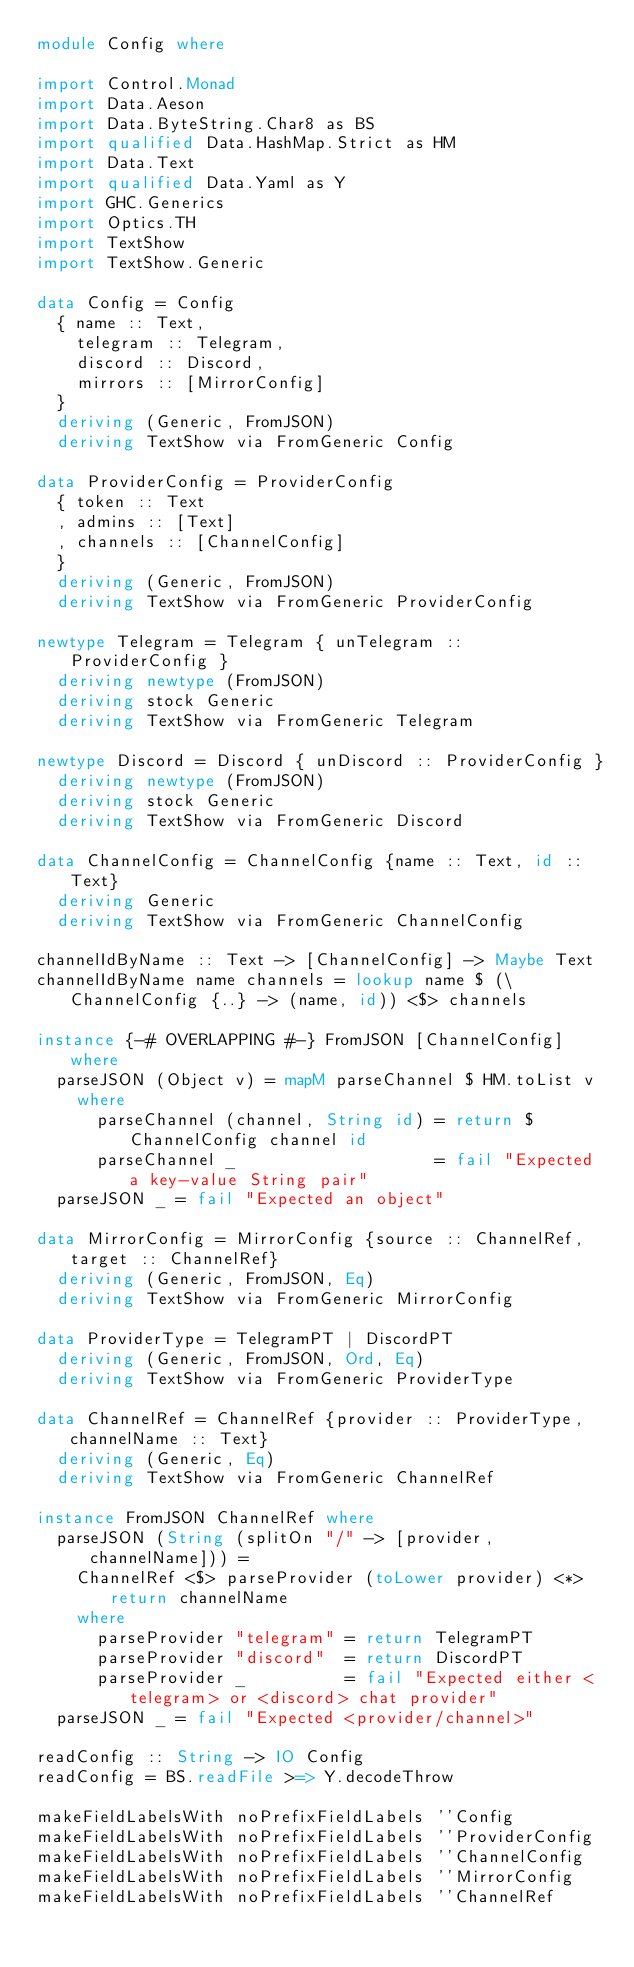<code> <loc_0><loc_0><loc_500><loc_500><_Haskell_>module Config where

import Control.Monad
import Data.Aeson
import Data.ByteString.Char8 as BS
import qualified Data.HashMap.Strict as HM
import Data.Text
import qualified Data.Yaml as Y
import GHC.Generics
import Optics.TH
import TextShow
import TextShow.Generic

data Config = Config
  { name :: Text,
    telegram :: Telegram,
    discord :: Discord,
    mirrors :: [MirrorConfig]
  }
  deriving (Generic, FromJSON)
  deriving TextShow via FromGeneric Config

data ProviderConfig = ProviderConfig
  { token :: Text
  , admins :: [Text]
  , channels :: [ChannelConfig]
  }
  deriving (Generic, FromJSON)
  deriving TextShow via FromGeneric ProviderConfig

newtype Telegram = Telegram { unTelegram :: ProviderConfig }
  deriving newtype (FromJSON)
  deriving stock Generic
  deriving TextShow via FromGeneric Telegram

newtype Discord = Discord { unDiscord :: ProviderConfig }
  deriving newtype (FromJSON)
  deriving stock Generic
  deriving TextShow via FromGeneric Discord

data ChannelConfig = ChannelConfig {name :: Text, id :: Text}
  deriving Generic
  deriving TextShow via FromGeneric ChannelConfig

channelIdByName :: Text -> [ChannelConfig] -> Maybe Text
channelIdByName name channels = lookup name $ (\ChannelConfig {..} -> (name, id)) <$> channels

instance {-# OVERLAPPING #-} FromJSON [ChannelConfig] where
  parseJSON (Object v) = mapM parseChannel $ HM.toList v
    where
      parseChannel (channel, String id) = return $ ChannelConfig channel id
      parseChannel _                    = fail "Expected a key-value String pair"
  parseJSON _ = fail "Expected an object"

data MirrorConfig = MirrorConfig {source :: ChannelRef, target :: ChannelRef}
  deriving (Generic, FromJSON, Eq)
  deriving TextShow via FromGeneric MirrorConfig

data ProviderType = TelegramPT | DiscordPT
  deriving (Generic, FromJSON, Ord, Eq)
  deriving TextShow via FromGeneric ProviderType

data ChannelRef = ChannelRef {provider :: ProviderType, channelName :: Text}
  deriving (Generic, Eq)
  deriving TextShow via FromGeneric ChannelRef

instance FromJSON ChannelRef where
  parseJSON (String (splitOn "/" -> [provider, channelName])) =
    ChannelRef <$> parseProvider (toLower provider) <*> return channelName
    where
      parseProvider "telegram" = return TelegramPT
      parseProvider "discord"  = return DiscordPT
      parseProvider _          = fail "Expected either <telegram> or <discord> chat provider"
  parseJSON _ = fail "Expected <provider/channel>"

readConfig :: String -> IO Config
readConfig = BS.readFile >=> Y.decodeThrow

makeFieldLabelsWith noPrefixFieldLabels ''Config
makeFieldLabelsWith noPrefixFieldLabels ''ProviderConfig
makeFieldLabelsWith noPrefixFieldLabels ''ChannelConfig
makeFieldLabelsWith noPrefixFieldLabels ''MirrorConfig
makeFieldLabelsWith noPrefixFieldLabels ''ChannelRef
</code> 